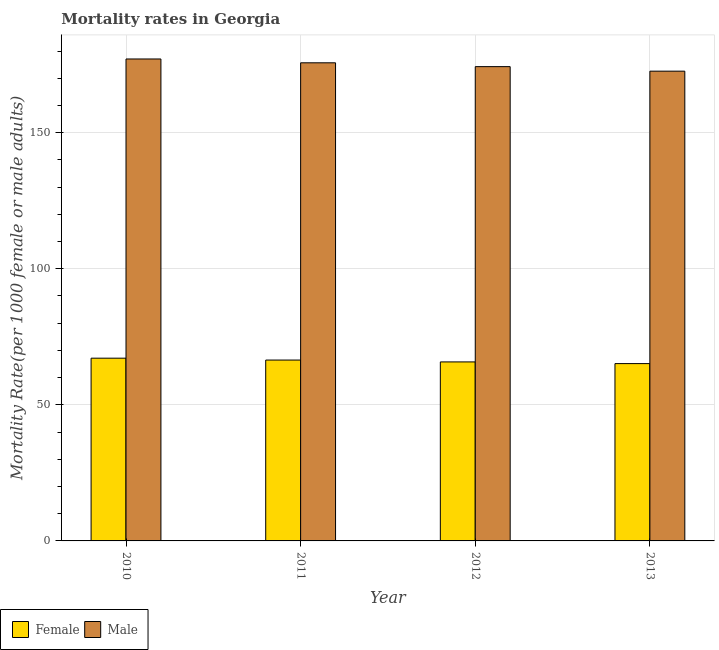How many groups of bars are there?
Your answer should be compact. 4. Are the number of bars on each tick of the X-axis equal?
Offer a very short reply. Yes. How many bars are there on the 3rd tick from the left?
Give a very brief answer. 2. How many bars are there on the 4th tick from the right?
Offer a terse response. 2. What is the label of the 1st group of bars from the left?
Offer a terse response. 2010. In how many cases, is the number of bars for a given year not equal to the number of legend labels?
Make the answer very short. 0. What is the male mortality rate in 2012?
Give a very brief answer. 174.27. Across all years, what is the maximum male mortality rate?
Offer a very short reply. 177.09. Across all years, what is the minimum female mortality rate?
Ensure brevity in your answer.  65.15. In which year was the male mortality rate minimum?
Ensure brevity in your answer.  2013. What is the total female mortality rate in the graph?
Keep it short and to the point. 264.53. What is the difference between the male mortality rate in 2011 and that in 2012?
Make the answer very short. 1.41. What is the difference between the male mortality rate in 2013 and the female mortality rate in 2012?
Provide a succinct answer. -1.66. What is the average female mortality rate per year?
Provide a short and direct response. 66.13. In the year 2010, what is the difference between the female mortality rate and male mortality rate?
Your answer should be compact. 0. What is the ratio of the female mortality rate in 2010 to that in 2012?
Provide a short and direct response. 1.02. What is the difference between the highest and the second highest male mortality rate?
Make the answer very short. 1.41. What is the difference between the highest and the lowest female mortality rate?
Your answer should be compact. 1.99. What does the 1st bar from the right in 2010 represents?
Your answer should be compact. Male. How many years are there in the graph?
Offer a terse response. 4. Does the graph contain any zero values?
Ensure brevity in your answer.  No. How are the legend labels stacked?
Ensure brevity in your answer.  Horizontal. What is the title of the graph?
Keep it short and to the point. Mortality rates in Georgia. What is the label or title of the X-axis?
Your answer should be compact. Year. What is the label or title of the Y-axis?
Your response must be concise. Mortality Rate(per 1000 female or male adults). What is the Mortality Rate(per 1000 female or male adults) in Female in 2010?
Ensure brevity in your answer.  67.14. What is the Mortality Rate(per 1000 female or male adults) in Male in 2010?
Provide a succinct answer. 177.09. What is the Mortality Rate(per 1000 female or male adults) in Female in 2011?
Your answer should be very brief. 66.46. What is the Mortality Rate(per 1000 female or male adults) of Male in 2011?
Keep it short and to the point. 175.68. What is the Mortality Rate(per 1000 female or male adults) of Female in 2012?
Ensure brevity in your answer.  65.77. What is the Mortality Rate(per 1000 female or male adults) of Male in 2012?
Your answer should be very brief. 174.27. What is the Mortality Rate(per 1000 female or male adults) in Female in 2013?
Your answer should be very brief. 65.15. What is the Mortality Rate(per 1000 female or male adults) of Male in 2013?
Keep it short and to the point. 172.61. Across all years, what is the maximum Mortality Rate(per 1000 female or male adults) in Female?
Your answer should be compact. 67.14. Across all years, what is the maximum Mortality Rate(per 1000 female or male adults) of Male?
Offer a very short reply. 177.09. Across all years, what is the minimum Mortality Rate(per 1000 female or male adults) in Female?
Ensure brevity in your answer.  65.15. Across all years, what is the minimum Mortality Rate(per 1000 female or male adults) in Male?
Your response must be concise. 172.61. What is the total Mortality Rate(per 1000 female or male adults) in Female in the graph?
Provide a succinct answer. 264.53. What is the total Mortality Rate(per 1000 female or male adults) in Male in the graph?
Provide a succinct answer. 699.65. What is the difference between the Mortality Rate(per 1000 female or male adults) in Female in 2010 and that in 2011?
Give a very brief answer. 0.69. What is the difference between the Mortality Rate(per 1000 female or male adults) in Male in 2010 and that in 2011?
Keep it short and to the point. 1.41. What is the difference between the Mortality Rate(per 1000 female or male adults) of Female in 2010 and that in 2012?
Make the answer very short. 1.37. What is the difference between the Mortality Rate(per 1000 female or male adults) in Male in 2010 and that in 2012?
Your answer should be compact. 2.82. What is the difference between the Mortality Rate(per 1000 female or male adults) of Female in 2010 and that in 2013?
Your answer should be very brief. 1.99. What is the difference between the Mortality Rate(per 1000 female or male adults) of Male in 2010 and that in 2013?
Offer a very short reply. 4.48. What is the difference between the Mortality Rate(per 1000 female or male adults) of Female in 2011 and that in 2012?
Keep it short and to the point. 0.69. What is the difference between the Mortality Rate(per 1000 female or male adults) in Male in 2011 and that in 2012?
Offer a terse response. 1.41. What is the difference between the Mortality Rate(per 1000 female or male adults) of Female in 2011 and that in 2013?
Your answer should be very brief. 1.3. What is the difference between the Mortality Rate(per 1000 female or male adults) of Male in 2011 and that in 2013?
Keep it short and to the point. 3.07. What is the difference between the Mortality Rate(per 1000 female or male adults) of Female in 2012 and that in 2013?
Provide a succinct answer. 0.62. What is the difference between the Mortality Rate(per 1000 female or male adults) in Male in 2012 and that in 2013?
Your answer should be compact. 1.66. What is the difference between the Mortality Rate(per 1000 female or male adults) in Female in 2010 and the Mortality Rate(per 1000 female or male adults) in Male in 2011?
Ensure brevity in your answer.  -108.54. What is the difference between the Mortality Rate(per 1000 female or male adults) in Female in 2010 and the Mortality Rate(per 1000 female or male adults) in Male in 2012?
Your response must be concise. -107.13. What is the difference between the Mortality Rate(per 1000 female or male adults) in Female in 2010 and the Mortality Rate(per 1000 female or male adults) in Male in 2013?
Give a very brief answer. -105.47. What is the difference between the Mortality Rate(per 1000 female or male adults) of Female in 2011 and the Mortality Rate(per 1000 female or male adults) of Male in 2012?
Your answer should be very brief. -107.81. What is the difference between the Mortality Rate(per 1000 female or male adults) in Female in 2011 and the Mortality Rate(per 1000 female or male adults) in Male in 2013?
Offer a terse response. -106.15. What is the difference between the Mortality Rate(per 1000 female or male adults) of Female in 2012 and the Mortality Rate(per 1000 female or male adults) of Male in 2013?
Keep it short and to the point. -106.84. What is the average Mortality Rate(per 1000 female or male adults) of Female per year?
Offer a very short reply. 66.13. What is the average Mortality Rate(per 1000 female or male adults) in Male per year?
Your response must be concise. 174.91. In the year 2010, what is the difference between the Mortality Rate(per 1000 female or male adults) in Female and Mortality Rate(per 1000 female or male adults) in Male?
Provide a succinct answer. -109.94. In the year 2011, what is the difference between the Mortality Rate(per 1000 female or male adults) in Female and Mortality Rate(per 1000 female or male adults) in Male?
Offer a very short reply. -109.22. In the year 2012, what is the difference between the Mortality Rate(per 1000 female or male adults) in Female and Mortality Rate(per 1000 female or male adults) in Male?
Your response must be concise. -108.5. In the year 2013, what is the difference between the Mortality Rate(per 1000 female or male adults) of Female and Mortality Rate(per 1000 female or male adults) of Male?
Offer a terse response. -107.46. What is the ratio of the Mortality Rate(per 1000 female or male adults) of Female in 2010 to that in 2011?
Keep it short and to the point. 1.01. What is the ratio of the Mortality Rate(per 1000 female or male adults) in Male in 2010 to that in 2011?
Make the answer very short. 1.01. What is the ratio of the Mortality Rate(per 1000 female or male adults) of Female in 2010 to that in 2012?
Ensure brevity in your answer.  1.02. What is the ratio of the Mortality Rate(per 1000 female or male adults) of Male in 2010 to that in 2012?
Keep it short and to the point. 1.02. What is the ratio of the Mortality Rate(per 1000 female or male adults) of Female in 2010 to that in 2013?
Offer a very short reply. 1.03. What is the ratio of the Mortality Rate(per 1000 female or male adults) of Male in 2010 to that in 2013?
Ensure brevity in your answer.  1.03. What is the ratio of the Mortality Rate(per 1000 female or male adults) of Female in 2011 to that in 2012?
Keep it short and to the point. 1.01. What is the ratio of the Mortality Rate(per 1000 female or male adults) of Male in 2011 to that in 2012?
Your answer should be compact. 1.01. What is the ratio of the Mortality Rate(per 1000 female or male adults) in Female in 2011 to that in 2013?
Provide a short and direct response. 1.02. What is the ratio of the Mortality Rate(per 1000 female or male adults) in Male in 2011 to that in 2013?
Provide a succinct answer. 1.02. What is the ratio of the Mortality Rate(per 1000 female or male adults) of Female in 2012 to that in 2013?
Ensure brevity in your answer.  1.01. What is the ratio of the Mortality Rate(per 1000 female or male adults) of Male in 2012 to that in 2013?
Your answer should be very brief. 1.01. What is the difference between the highest and the second highest Mortality Rate(per 1000 female or male adults) in Female?
Offer a terse response. 0.69. What is the difference between the highest and the second highest Mortality Rate(per 1000 female or male adults) in Male?
Your answer should be compact. 1.41. What is the difference between the highest and the lowest Mortality Rate(per 1000 female or male adults) in Female?
Keep it short and to the point. 1.99. What is the difference between the highest and the lowest Mortality Rate(per 1000 female or male adults) in Male?
Your answer should be very brief. 4.48. 